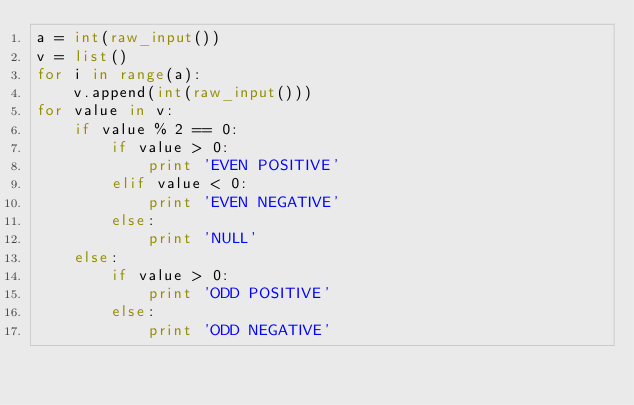Convert code to text. <code><loc_0><loc_0><loc_500><loc_500><_Python_>a = int(raw_input())
v = list()
for i in range(a):
    v.append(int(raw_input()))
for value in v:
    if value % 2 == 0:
        if value > 0:
            print 'EVEN POSITIVE'
        elif value < 0:
            print 'EVEN NEGATIVE'
        else:
            print 'NULL'
    else:
        if value > 0:
            print 'ODD POSITIVE'
        else:
            print 'ODD NEGATIVE'
        
</code> 